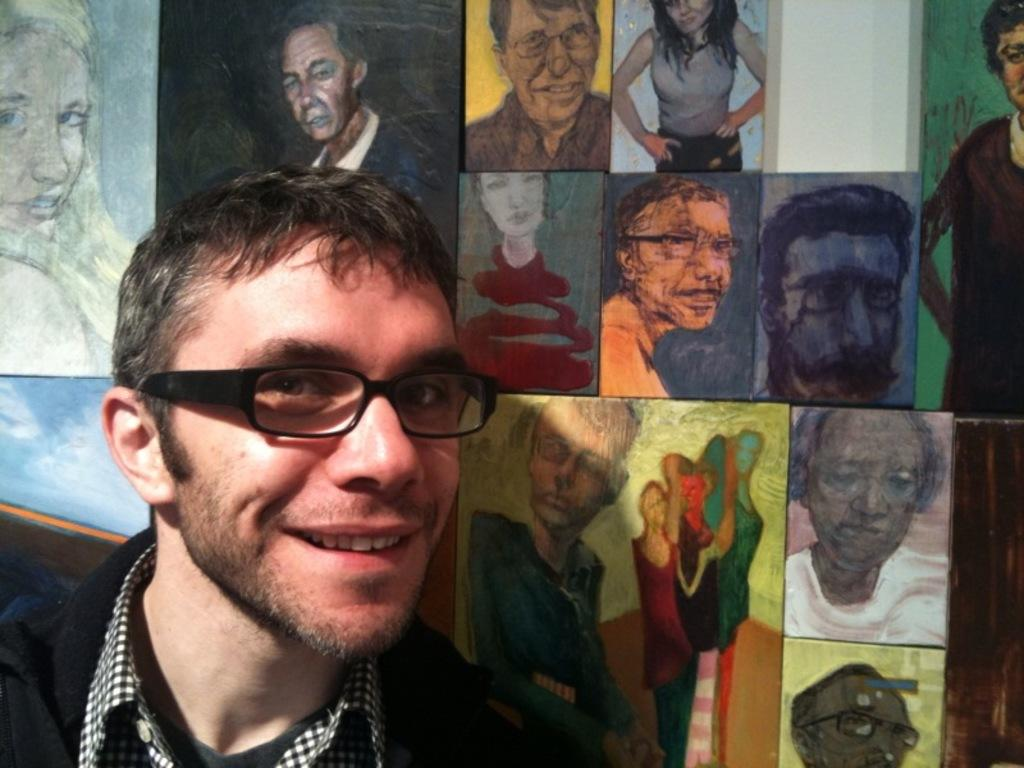What is the main subject of the image? There is a man in the image. What is the man's facial expression? The man is smiling. Can you describe any additional features in the image? There are frames attached to an object in the image. What color is the man's sweater in the image? There is no mention of a sweater in the image, so we cannot determine its color. How many feet does the man have in the image? The image only shows the man from the waist up, so we cannot determine the number of feet he has. 